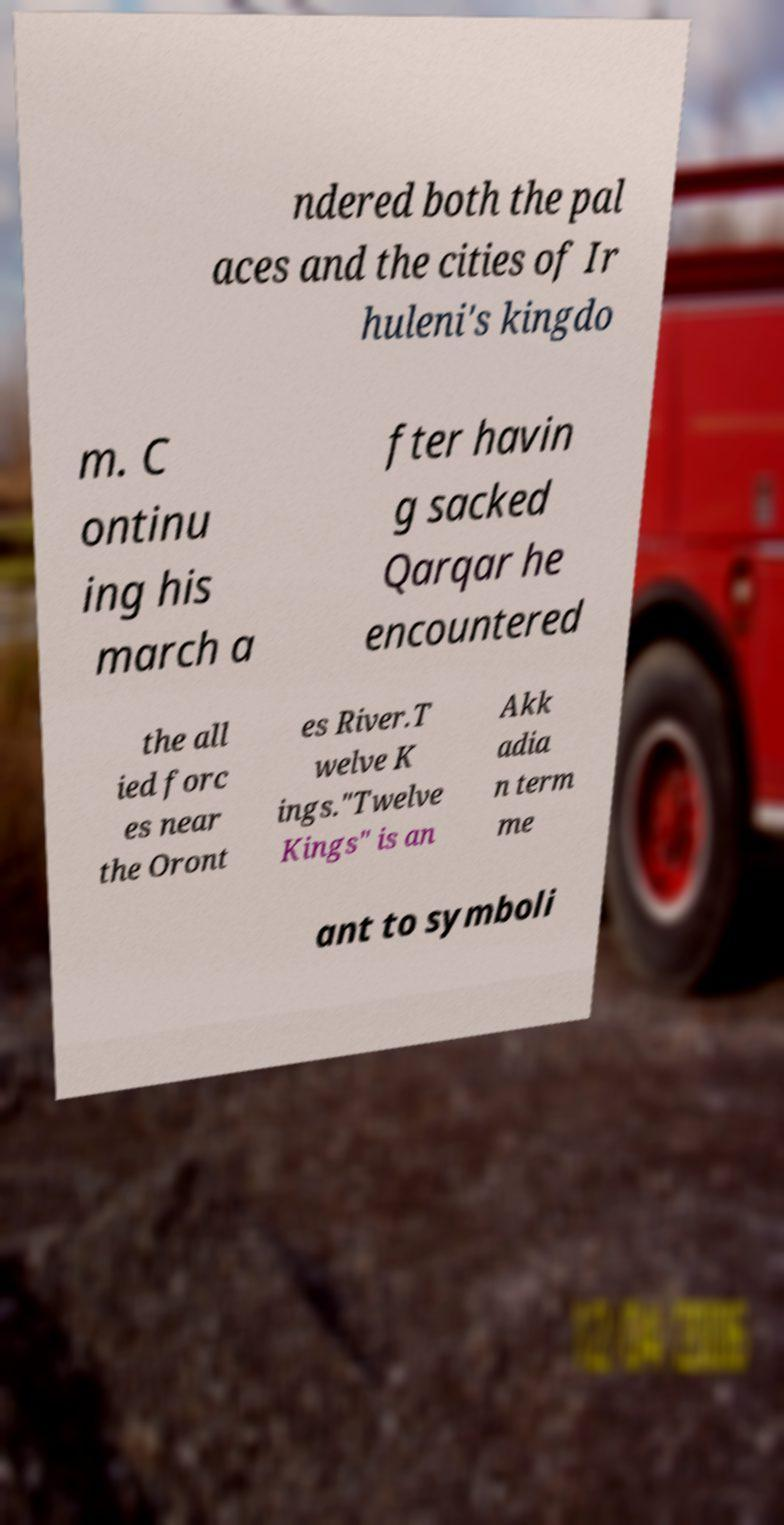Can you accurately transcribe the text from the provided image for me? ndered both the pal aces and the cities of Ir huleni's kingdo m. C ontinu ing his march a fter havin g sacked Qarqar he encountered the all ied forc es near the Oront es River.T welve K ings."Twelve Kings" is an Akk adia n term me ant to symboli 